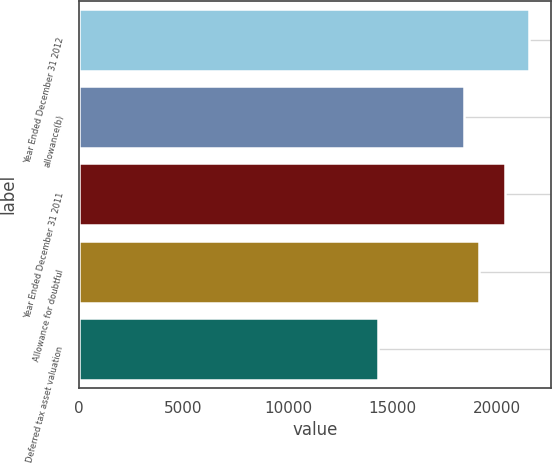Convert chart to OTSL. <chart><loc_0><loc_0><loc_500><loc_500><bar_chart><fcel>Year Ended December 31 2012<fcel>allowance(b)<fcel>Year Ended December 31 2011<fcel>Allowance for doubtful<fcel>Deferred tax asset valuation<nl><fcel>21491<fcel>18405.5<fcel>20351<fcel>19125<fcel>14296<nl></chart> 